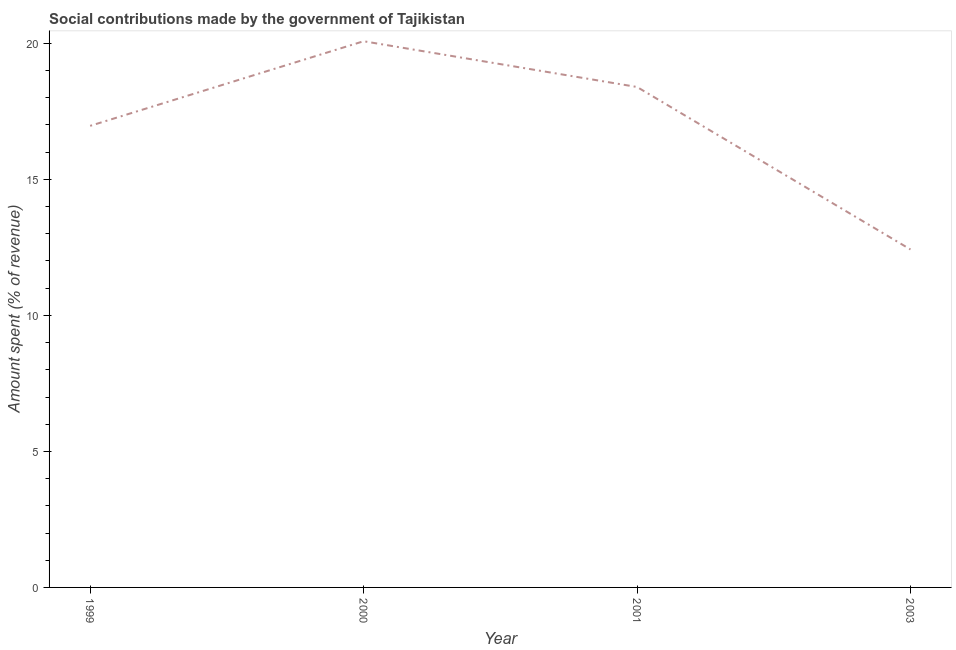What is the amount spent in making social contributions in 1999?
Your answer should be very brief. 16.97. Across all years, what is the maximum amount spent in making social contributions?
Ensure brevity in your answer.  20.08. Across all years, what is the minimum amount spent in making social contributions?
Give a very brief answer. 12.42. What is the sum of the amount spent in making social contributions?
Offer a terse response. 67.87. What is the difference between the amount spent in making social contributions in 2001 and 2003?
Give a very brief answer. 5.97. What is the average amount spent in making social contributions per year?
Offer a very short reply. 16.97. What is the median amount spent in making social contributions?
Ensure brevity in your answer.  17.68. In how many years, is the amount spent in making social contributions greater than 12 %?
Make the answer very short. 4. Do a majority of the years between 2003 and 2000 (inclusive) have amount spent in making social contributions greater than 15 %?
Your answer should be compact. No. What is the ratio of the amount spent in making social contributions in 1999 to that in 2000?
Make the answer very short. 0.85. Is the amount spent in making social contributions in 1999 less than that in 2001?
Ensure brevity in your answer.  Yes. Is the difference between the amount spent in making social contributions in 1999 and 2003 greater than the difference between any two years?
Make the answer very short. No. What is the difference between the highest and the second highest amount spent in making social contributions?
Your answer should be compact. 1.68. Is the sum of the amount spent in making social contributions in 1999 and 2003 greater than the maximum amount spent in making social contributions across all years?
Your answer should be very brief. Yes. What is the difference between the highest and the lowest amount spent in making social contributions?
Offer a very short reply. 7.65. In how many years, is the amount spent in making social contributions greater than the average amount spent in making social contributions taken over all years?
Provide a succinct answer. 3. Does the amount spent in making social contributions monotonically increase over the years?
Make the answer very short. No. How many lines are there?
Provide a short and direct response. 1. What is the difference between two consecutive major ticks on the Y-axis?
Offer a terse response. 5. Are the values on the major ticks of Y-axis written in scientific E-notation?
Provide a succinct answer. No. What is the title of the graph?
Offer a terse response. Social contributions made by the government of Tajikistan. What is the label or title of the Y-axis?
Your response must be concise. Amount spent (% of revenue). What is the Amount spent (% of revenue) in 1999?
Give a very brief answer. 16.97. What is the Amount spent (% of revenue) in 2000?
Provide a succinct answer. 20.08. What is the Amount spent (% of revenue) in 2001?
Provide a succinct answer. 18.4. What is the Amount spent (% of revenue) of 2003?
Keep it short and to the point. 12.42. What is the difference between the Amount spent (% of revenue) in 1999 and 2000?
Offer a terse response. -3.11. What is the difference between the Amount spent (% of revenue) in 1999 and 2001?
Your answer should be very brief. -1.43. What is the difference between the Amount spent (% of revenue) in 1999 and 2003?
Offer a very short reply. 4.54. What is the difference between the Amount spent (% of revenue) in 2000 and 2001?
Offer a terse response. 1.68. What is the difference between the Amount spent (% of revenue) in 2000 and 2003?
Your answer should be very brief. 7.65. What is the difference between the Amount spent (% of revenue) in 2001 and 2003?
Provide a succinct answer. 5.97. What is the ratio of the Amount spent (% of revenue) in 1999 to that in 2000?
Keep it short and to the point. 0.84. What is the ratio of the Amount spent (% of revenue) in 1999 to that in 2001?
Make the answer very short. 0.92. What is the ratio of the Amount spent (% of revenue) in 1999 to that in 2003?
Make the answer very short. 1.37. What is the ratio of the Amount spent (% of revenue) in 2000 to that in 2001?
Your response must be concise. 1.09. What is the ratio of the Amount spent (% of revenue) in 2000 to that in 2003?
Offer a terse response. 1.62. What is the ratio of the Amount spent (% of revenue) in 2001 to that in 2003?
Offer a very short reply. 1.48. 